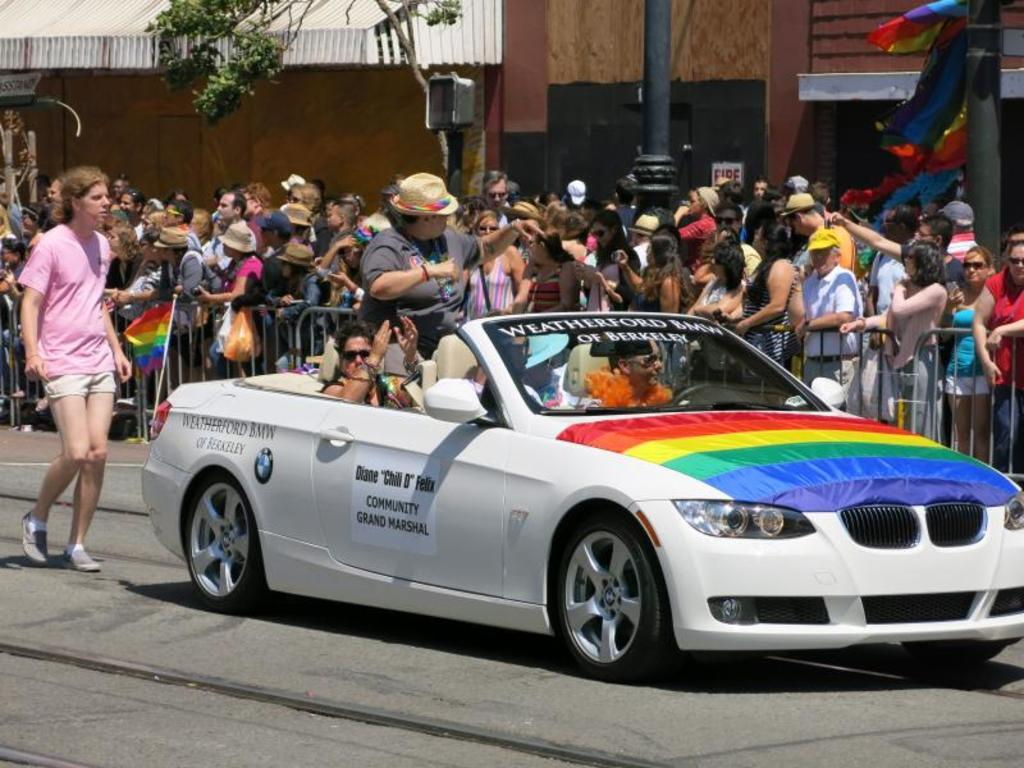How many people are in the image? There is a group of people in the image. What are the people in the image doing? The people are standing. What else can be seen in the image besides the group of people? There is a car visible on the road in the image. What type of stick is being used to force the orange to roll down the road in the image? There is no stick or orange present in the image; it only features a group of people standing and a car on the road. 